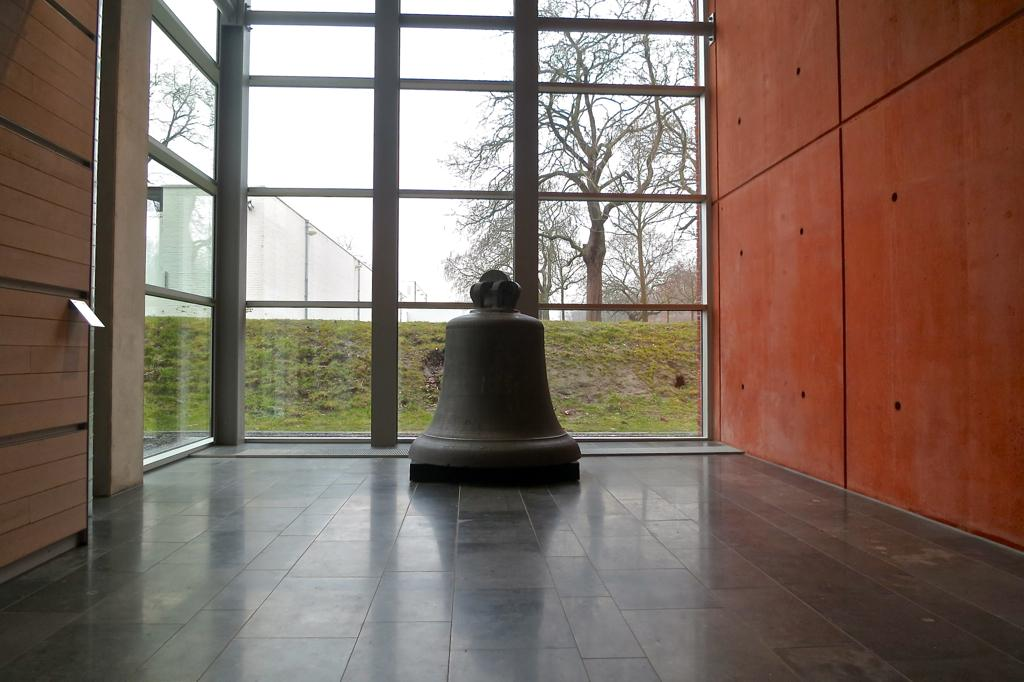What object can be seen in the image? There is a bell in the image. Where is the bell located? The bell is placed on the floor. What can be seen in the background of the image? There is grass, trees, and a building visible in the background of the image. How is the building visible in the image? The building is visible through a glass door in the background of the image. What type of bun is being used to hold the bell in the image? There is no bun present in the image; the bell is simply placed on the floor. 